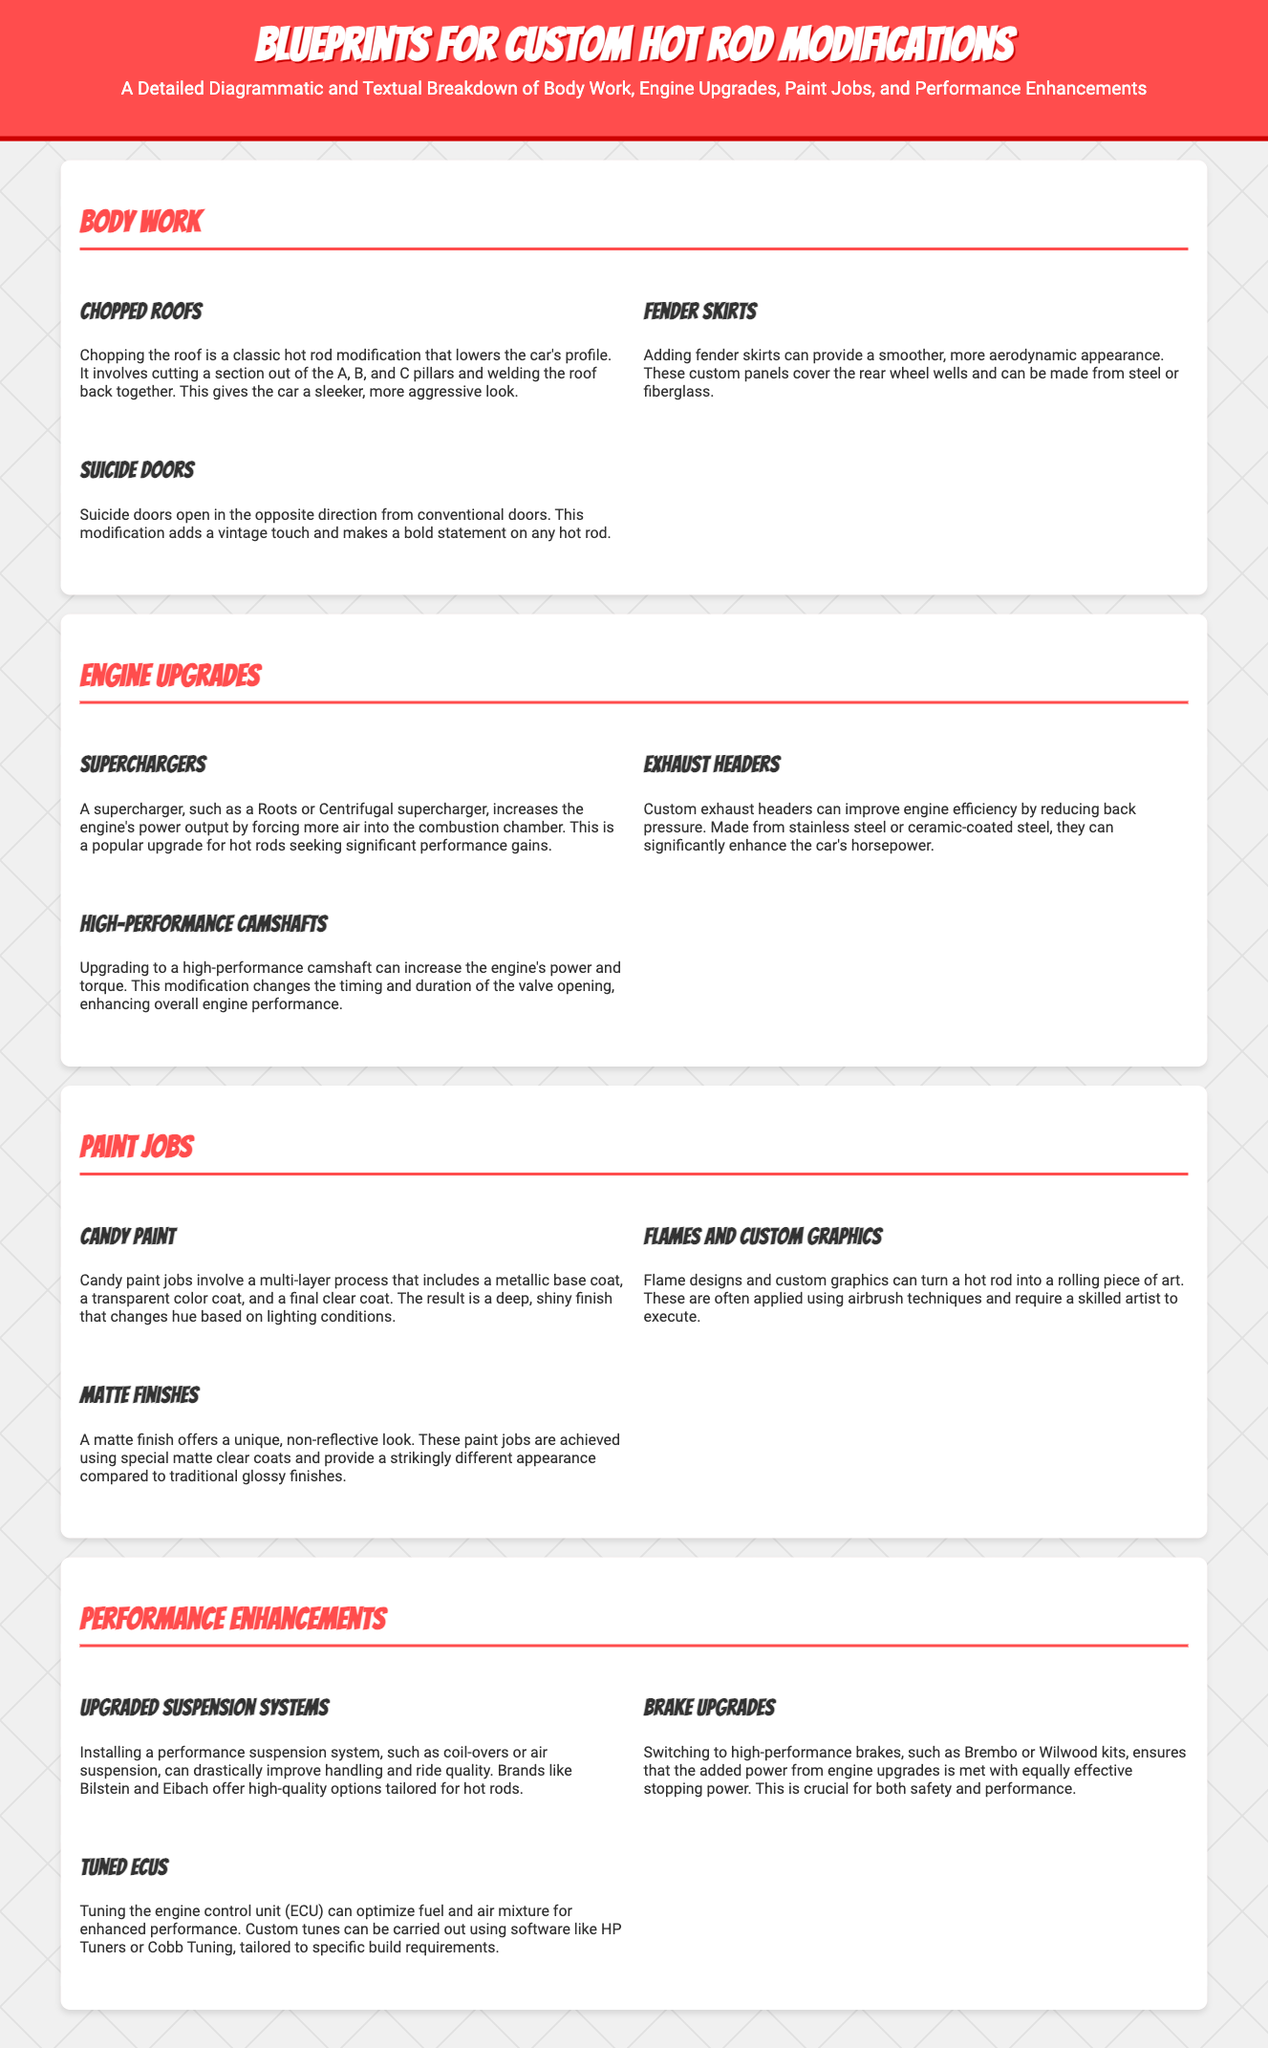What are fender skirts? Fender skirts are custom panels that cover the rear wheel wells, providing a smoother, more aerodynamic appearance.
Answer: Custom panels What is a supercharger used for? A supercharger increases the engine's power output by forcing more air into the combustion chamber.
Answer: Power output What are the three types of paint jobs mentioned? The paint jobs mentioned are Candy Paint, Flames and Custom Graphics, and Matte Finishes.
Answer: Candy Paint, Flames and Custom Graphics, Matte Finishes How can custom exhaust headers improve engine efficiency? Custom exhaust headers improve engine efficiency by reducing back pressure.
Answer: Reducing back pressure What is the effect of a high-performance camshaft? Upgrading to a high-performance camshaft increases the engine's power and torque.
Answer: Increases power and torque What is a benefit of installing a performance suspension system? A performance suspension system can drastically improve handling and ride quality.
Answer: Improve handling and ride quality What is a unique characteristic of matte finishes? A matte finish offers a unique, non-reflective look.
Answer: Non-reflective look What is the purpose of tuning the ECU? Tuning the ECU optimizes fuel and air mixture for enhanced performance.
Answer: Optimize fuel and air mixture 